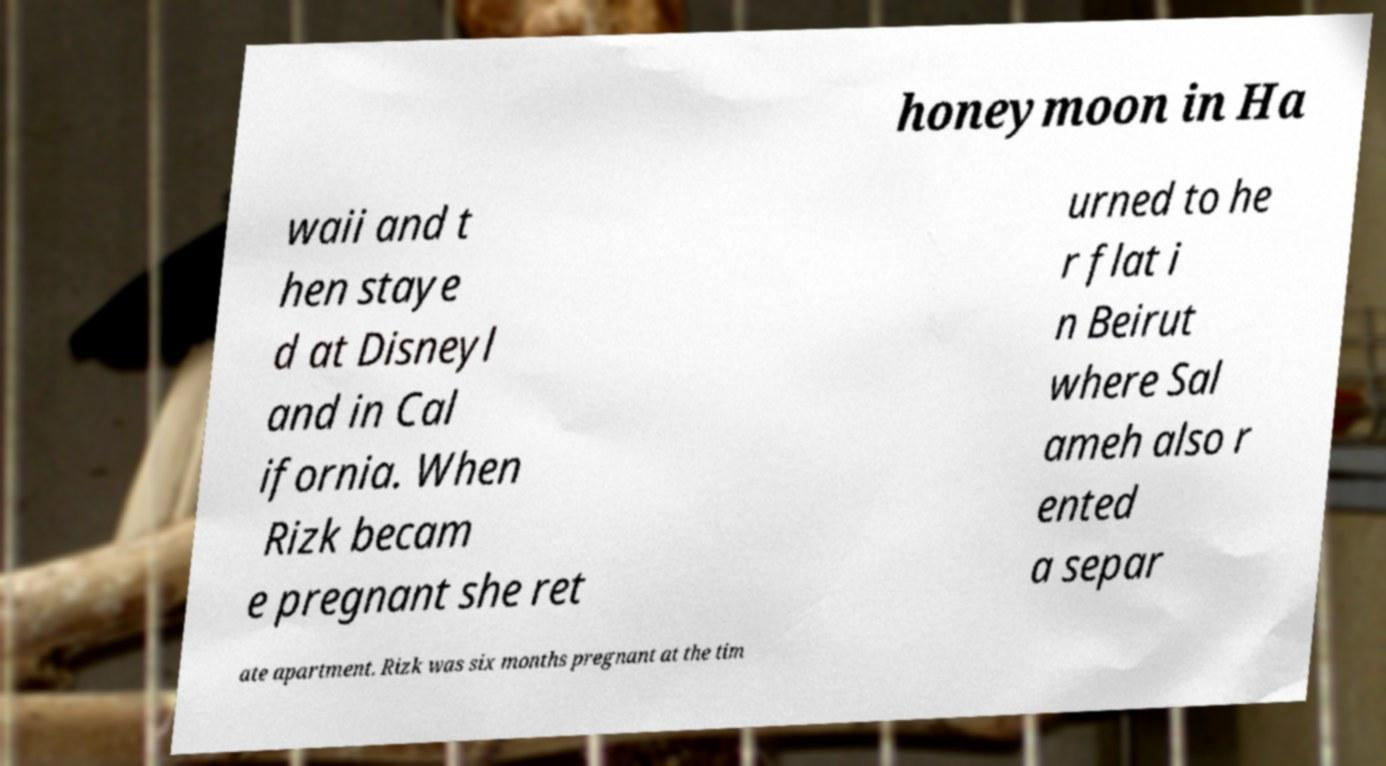What messages or text are displayed in this image? I need them in a readable, typed format. honeymoon in Ha waii and t hen staye d at Disneyl and in Cal ifornia. When Rizk becam e pregnant she ret urned to he r flat i n Beirut where Sal ameh also r ented a separ ate apartment. Rizk was six months pregnant at the tim 